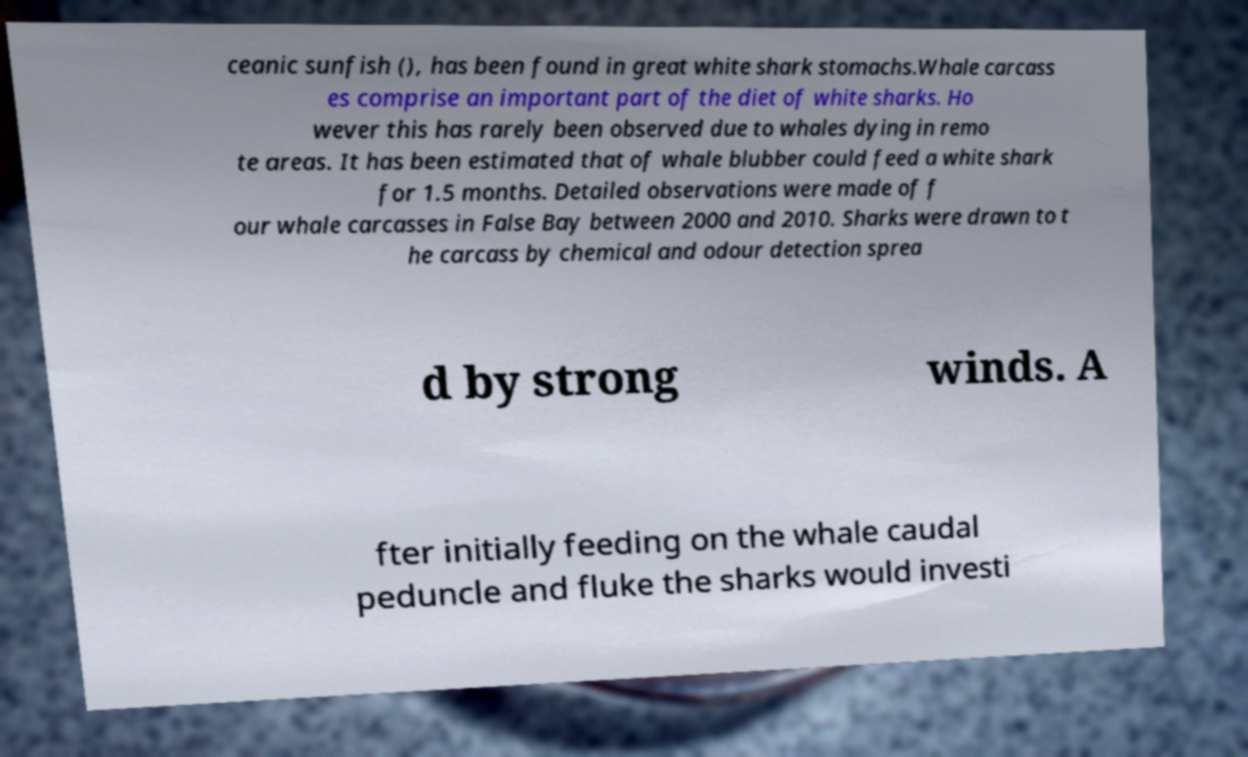Please identify and transcribe the text found in this image. ceanic sunfish (), has been found in great white shark stomachs.Whale carcass es comprise an important part of the diet of white sharks. Ho wever this has rarely been observed due to whales dying in remo te areas. It has been estimated that of whale blubber could feed a white shark for 1.5 months. Detailed observations were made of f our whale carcasses in False Bay between 2000 and 2010. Sharks were drawn to t he carcass by chemical and odour detection sprea d by strong winds. A fter initially feeding on the whale caudal peduncle and fluke the sharks would investi 